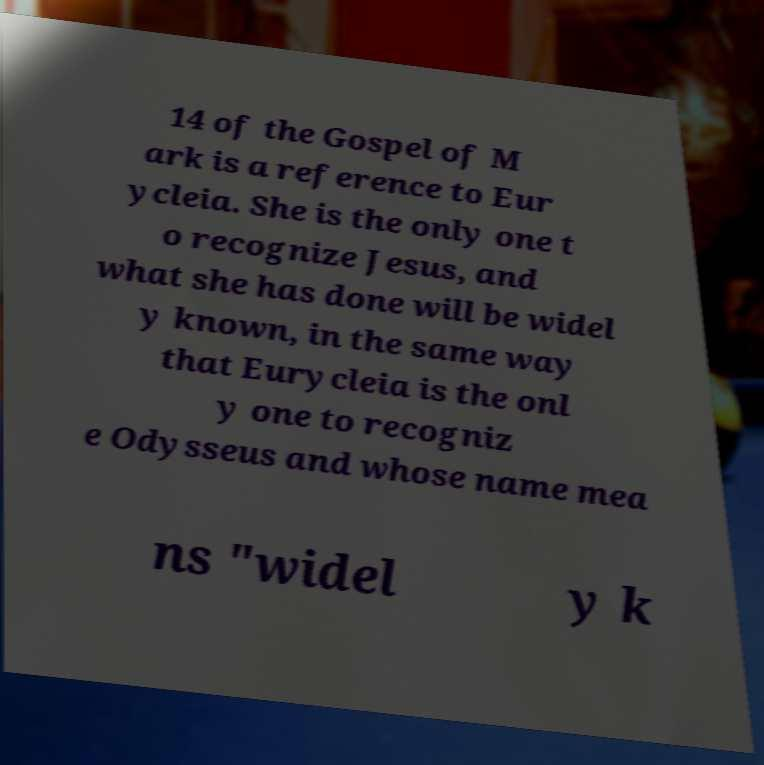Please identify and transcribe the text found in this image. 14 of the Gospel of M ark is a reference to Eur ycleia. She is the only one t o recognize Jesus, and what she has done will be widel y known, in the same way that Eurycleia is the onl y one to recogniz e Odysseus and whose name mea ns "widel y k 